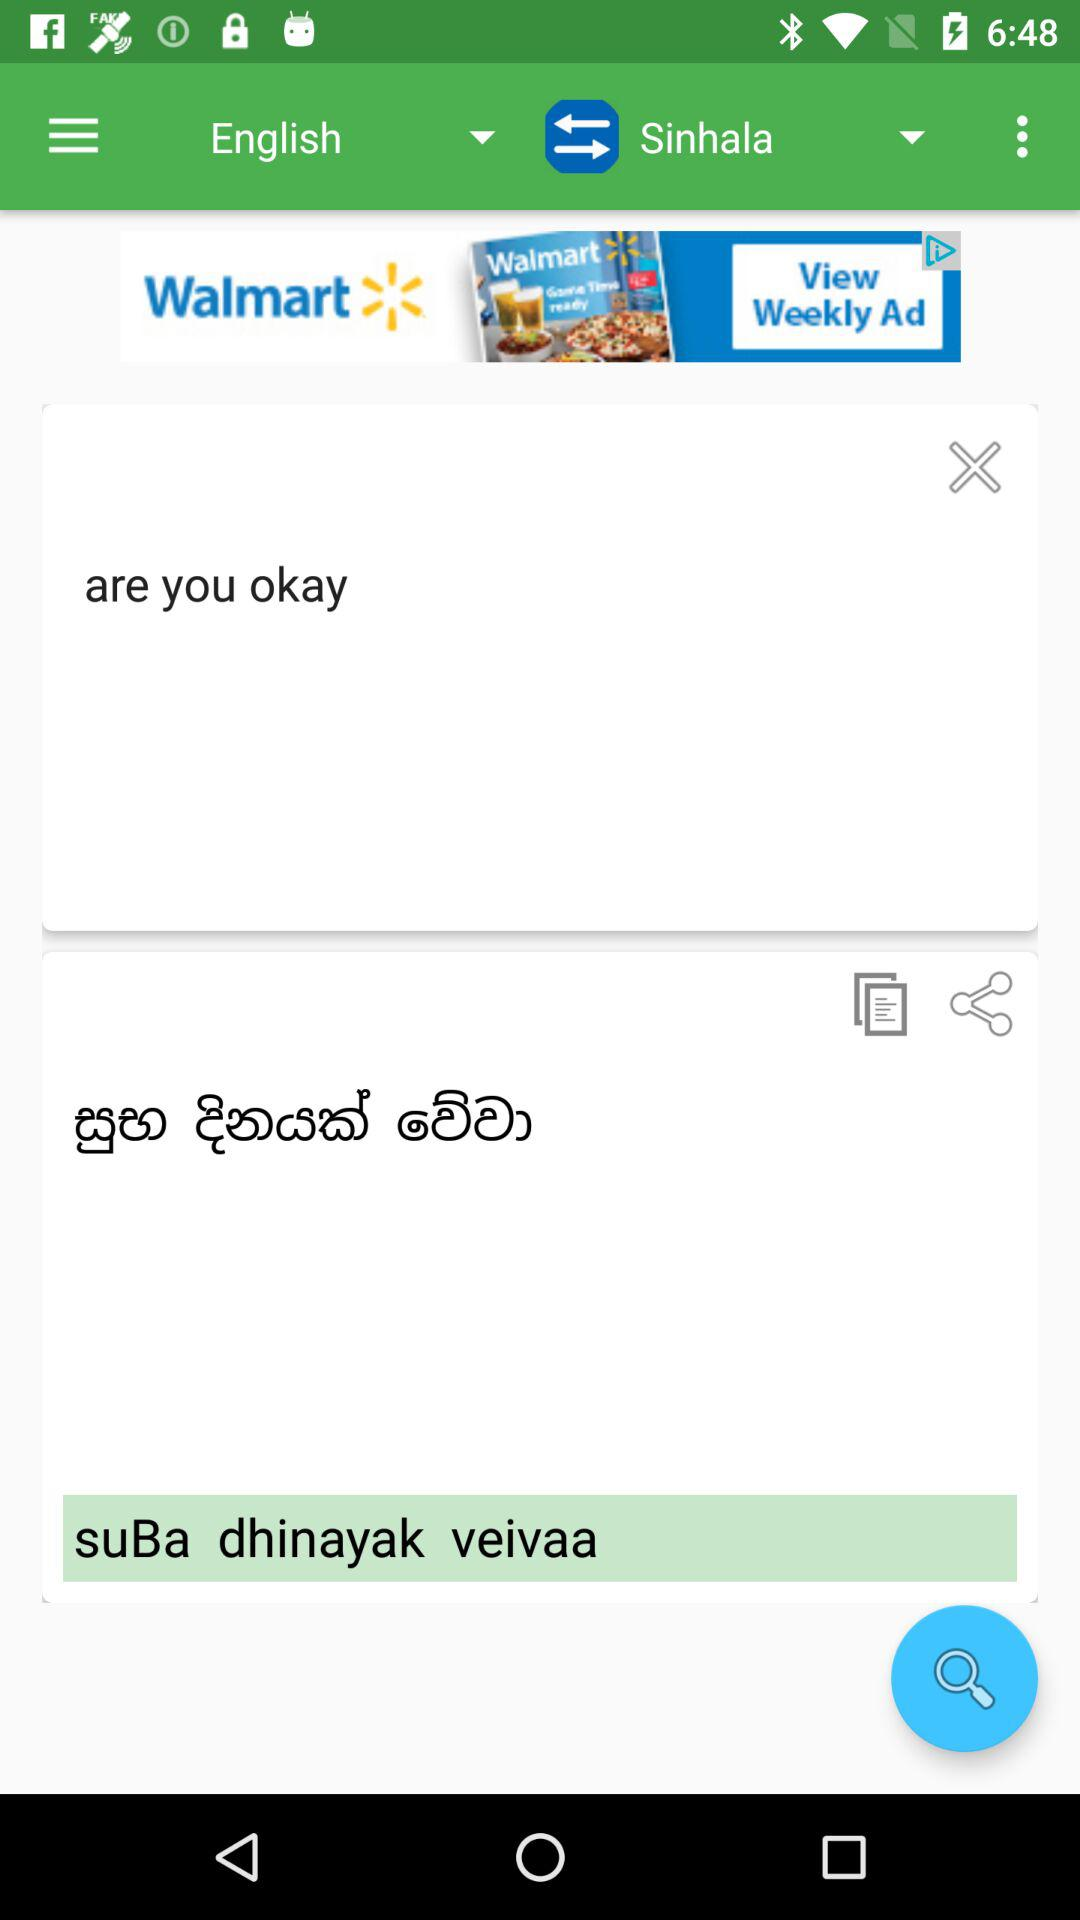What language is being translated into which language? English is being translated into Sinhala. 